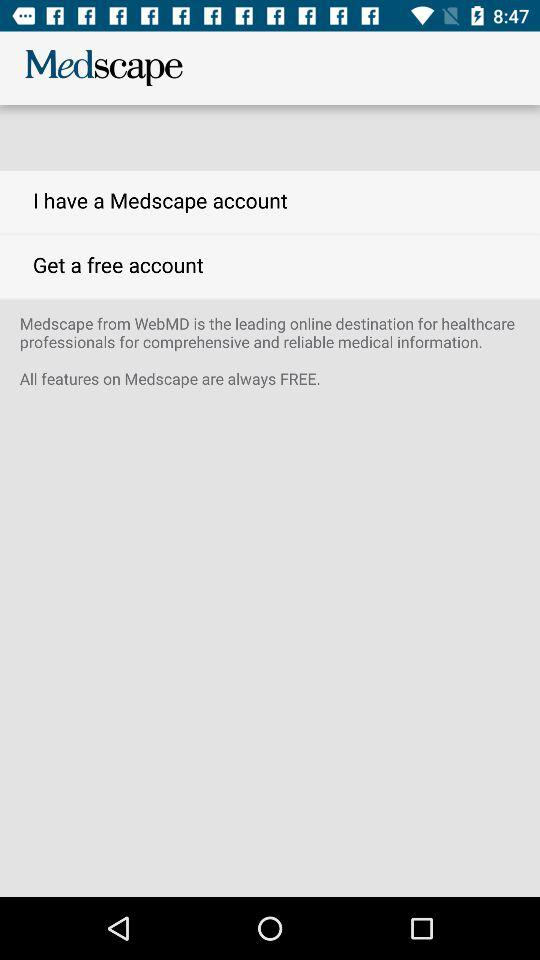How much does it cost to use all the features of "Medscape"? All the features of "Medscape" are free. 